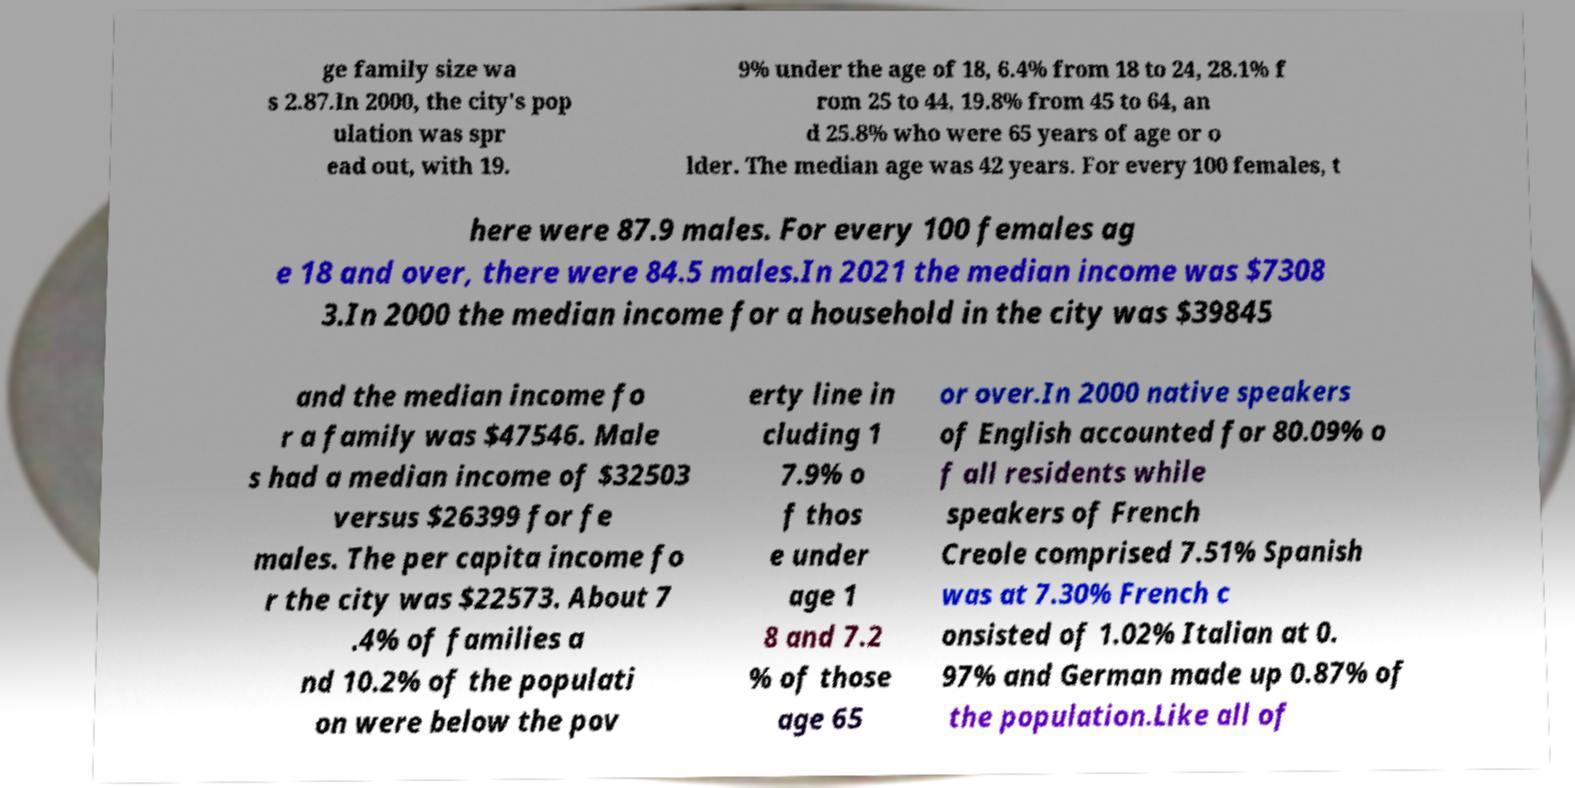There's text embedded in this image that I need extracted. Can you transcribe it verbatim? ge family size wa s 2.87.In 2000, the city's pop ulation was spr ead out, with 19. 9% under the age of 18, 6.4% from 18 to 24, 28.1% f rom 25 to 44, 19.8% from 45 to 64, an d 25.8% who were 65 years of age or o lder. The median age was 42 years. For every 100 females, t here were 87.9 males. For every 100 females ag e 18 and over, there were 84.5 males.In 2021 the median income was $7308 3.In 2000 the median income for a household in the city was $39845 and the median income fo r a family was $47546. Male s had a median income of $32503 versus $26399 for fe males. The per capita income fo r the city was $22573. About 7 .4% of families a nd 10.2% of the populati on were below the pov erty line in cluding 1 7.9% o f thos e under age 1 8 and 7.2 % of those age 65 or over.In 2000 native speakers of English accounted for 80.09% o f all residents while speakers of French Creole comprised 7.51% Spanish was at 7.30% French c onsisted of 1.02% Italian at 0. 97% and German made up 0.87% of the population.Like all of 